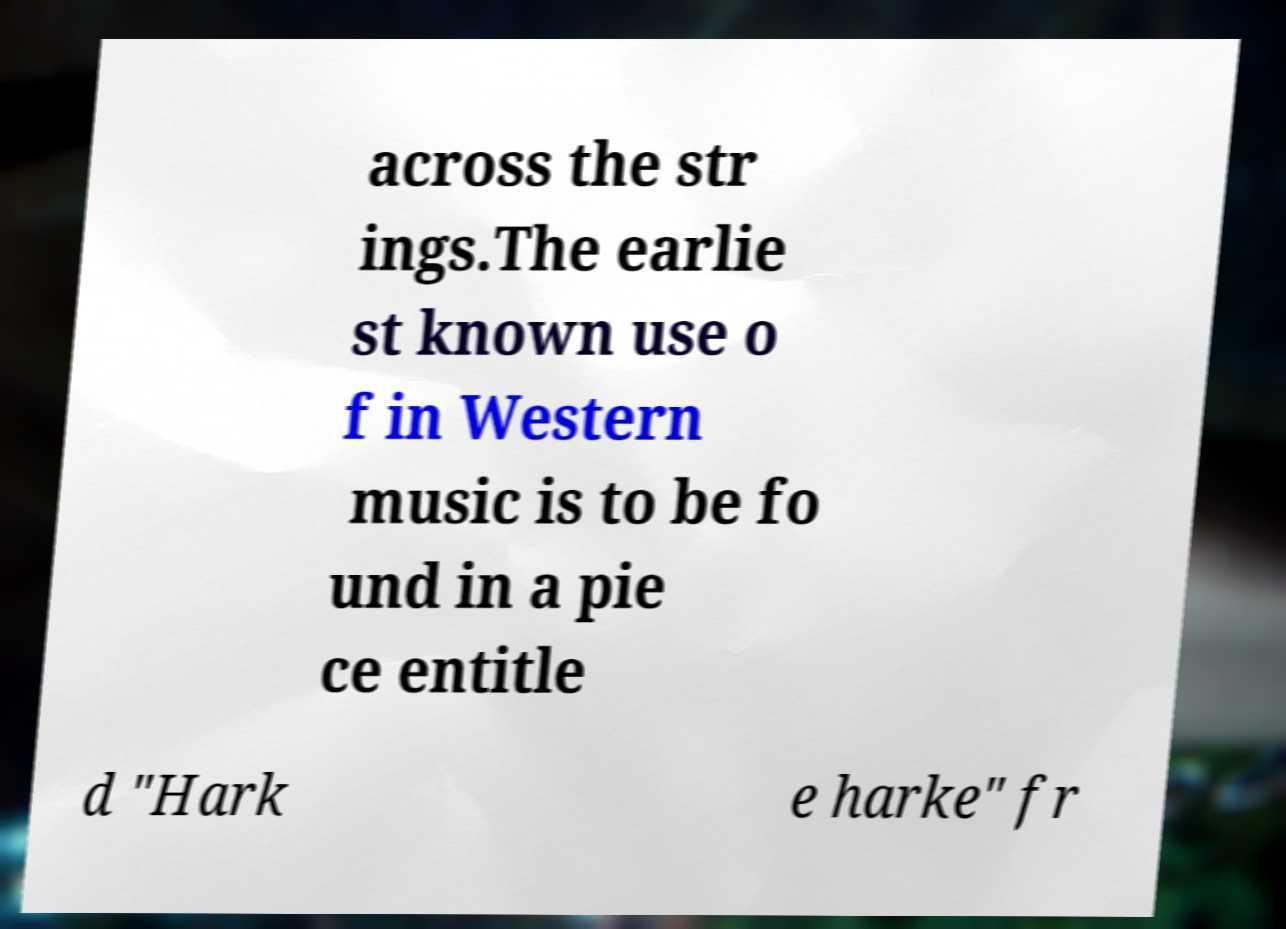Could you assist in decoding the text presented in this image and type it out clearly? across the str ings.The earlie st known use o f in Western music is to be fo und in a pie ce entitle d "Hark e harke" fr 